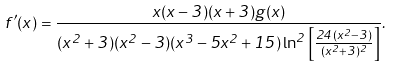<formula> <loc_0><loc_0><loc_500><loc_500>f ^ { \prime } ( x ) = \frac { x ( x - 3 ) ( x + 3 ) g ( x ) } { ( x ^ { 2 } + 3 ) ( x ^ { 2 } - 3 ) ( x ^ { 3 } - 5 x ^ { 2 } + 1 5 ) \ln ^ { 2 } { \left [ \frac { 2 4 ( x ^ { 2 } - 3 ) } { ( x ^ { 2 } + 3 ) ^ { 2 } } \right ] } } .</formula> 